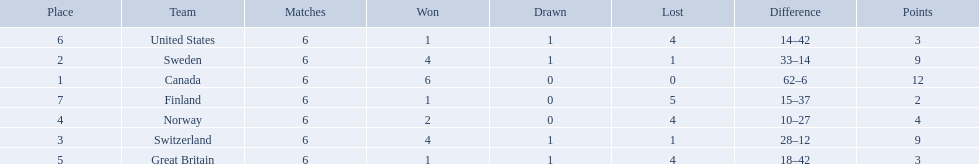What are the names of the countries? Canada, Sweden, Switzerland, Norway, Great Britain, United States, Finland. How many wins did switzerland have? 4. How many wins did great britain have? 1. Which country had more wins, great britain or switzerland? Switzerland. 